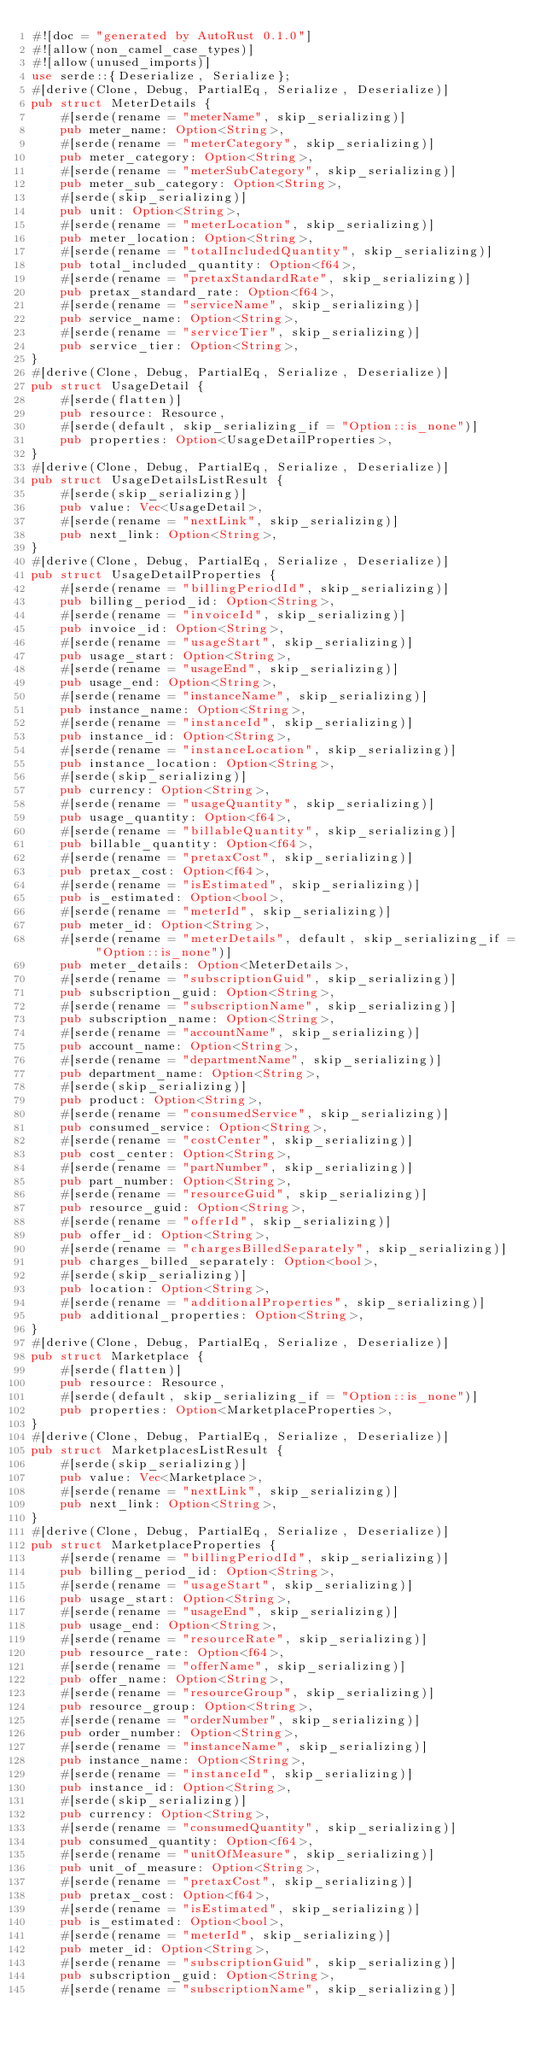Convert code to text. <code><loc_0><loc_0><loc_500><loc_500><_Rust_>#![doc = "generated by AutoRust 0.1.0"]
#![allow(non_camel_case_types)]
#![allow(unused_imports)]
use serde::{Deserialize, Serialize};
#[derive(Clone, Debug, PartialEq, Serialize, Deserialize)]
pub struct MeterDetails {
    #[serde(rename = "meterName", skip_serializing)]
    pub meter_name: Option<String>,
    #[serde(rename = "meterCategory", skip_serializing)]
    pub meter_category: Option<String>,
    #[serde(rename = "meterSubCategory", skip_serializing)]
    pub meter_sub_category: Option<String>,
    #[serde(skip_serializing)]
    pub unit: Option<String>,
    #[serde(rename = "meterLocation", skip_serializing)]
    pub meter_location: Option<String>,
    #[serde(rename = "totalIncludedQuantity", skip_serializing)]
    pub total_included_quantity: Option<f64>,
    #[serde(rename = "pretaxStandardRate", skip_serializing)]
    pub pretax_standard_rate: Option<f64>,
    #[serde(rename = "serviceName", skip_serializing)]
    pub service_name: Option<String>,
    #[serde(rename = "serviceTier", skip_serializing)]
    pub service_tier: Option<String>,
}
#[derive(Clone, Debug, PartialEq, Serialize, Deserialize)]
pub struct UsageDetail {
    #[serde(flatten)]
    pub resource: Resource,
    #[serde(default, skip_serializing_if = "Option::is_none")]
    pub properties: Option<UsageDetailProperties>,
}
#[derive(Clone, Debug, PartialEq, Serialize, Deserialize)]
pub struct UsageDetailsListResult {
    #[serde(skip_serializing)]
    pub value: Vec<UsageDetail>,
    #[serde(rename = "nextLink", skip_serializing)]
    pub next_link: Option<String>,
}
#[derive(Clone, Debug, PartialEq, Serialize, Deserialize)]
pub struct UsageDetailProperties {
    #[serde(rename = "billingPeriodId", skip_serializing)]
    pub billing_period_id: Option<String>,
    #[serde(rename = "invoiceId", skip_serializing)]
    pub invoice_id: Option<String>,
    #[serde(rename = "usageStart", skip_serializing)]
    pub usage_start: Option<String>,
    #[serde(rename = "usageEnd", skip_serializing)]
    pub usage_end: Option<String>,
    #[serde(rename = "instanceName", skip_serializing)]
    pub instance_name: Option<String>,
    #[serde(rename = "instanceId", skip_serializing)]
    pub instance_id: Option<String>,
    #[serde(rename = "instanceLocation", skip_serializing)]
    pub instance_location: Option<String>,
    #[serde(skip_serializing)]
    pub currency: Option<String>,
    #[serde(rename = "usageQuantity", skip_serializing)]
    pub usage_quantity: Option<f64>,
    #[serde(rename = "billableQuantity", skip_serializing)]
    pub billable_quantity: Option<f64>,
    #[serde(rename = "pretaxCost", skip_serializing)]
    pub pretax_cost: Option<f64>,
    #[serde(rename = "isEstimated", skip_serializing)]
    pub is_estimated: Option<bool>,
    #[serde(rename = "meterId", skip_serializing)]
    pub meter_id: Option<String>,
    #[serde(rename = "meterDetails", default, skip_serializing_if = "Option::is_none")]
    pub meter_details: Option<MeterDetails>,
    #[serde(rename = "subscriptionGuid", skip_serializing)]
    pub subscription_guid: Option<String>,
    #[serde(rename = "subscriptionName", skip_serializing)]
    pub subscription_name: Option<String>,
    #[serde(rename = "accountName", skip_serializing)]
    pub account_name: Option<String>,
    #[serde(rename = "departmentName", skip_serializing)]
    pub department_name: Option<String>,
    #[serde(skip_serializing)]
    pub product: Option<String>,
    #[serde(rename = "consumedService", skip_serializing)]
    pub consumed_service: Option<String>,
    #[serde(rename = "costCenter", skip_serializing)]
    pub cost_center: Option<String>,
    #[serde(rename = "partNumber", skip_serializing)]
    pub part_number: Option<String>,
    #[serde(rename = "resourceGuid", skip_serializing)]
    pub resource_guid: Option<String>,
    #[serde(rename = "offerId", skip_serializing)]
    pub offer_id: Option<String>,
    #[serde(rename = "chargesBilledSeparately", skip_serializing)]
    pub charges_billed_separately: Option<bool>,
    #[serde(skip_serializing)]
    pub location: Option<String>,
    #[serde(rename = "additionalProperties", skip_serializing)]
    pub additional_properties: Option<String>,
}
#[derive(Clone, Debug, PartialEq, Serialize, Deserialize)]
pub struct Marketplace {
    #[serde(flatten)]
    pub resource: Resource,
    #[serde(default, skip_serializing_if = "Option::is_none")]
    pub properties: Option<MarketplaceProperties>,
}
#[derive(Clone, Debug, PartialEq, Serialize, Deserialize)]
pub struct MarketplacesListResult {
    #[serde(skip_serializing)]
    pub value: Vec<Marketplace>,
    #[serde(rename = "nextLink", skip_serializing)]
    pub next_link: Option<String>,
}
#[derive(Clone, Debug, PartialEq, Serialize, Deserialize)]
pub struct MarketplaceProperties {
    #[serde(rename = "billingPeriodId", skip_serializing)]
    pub billing_period_id: Option<String>,
    #[serde(rename = "usageStart", skip_serializing)]
    pub usage_start: Option<String>,
    #[serde(rename = "usageEnd", skip_serializing)]
    pub usage_end: Option<String>,
    #[serde(rename = "resourceRate", skip_serializing)]
    pub resource_rate: Option<f64>,
    #[serde(rename = "offerName", skip_serializing)]
    pub offer_name: Option<String>,
    #[serde(rename = "resourceGroup", skip_serializing)]
    pub resource_group: Option<String>,
    #[serde(rename = "orderNumber", skip_serializing)]
    pub order_number: Option<String>,
    #[serde(rename = "instanceName", skip_serializing)]
    pub instance_name: Option<String>,
    #[serde(rename = "instanceId", skip_serializing)]
    pub instance_id: Option<String>,
    #[serde(skip_serializing)]
    pub currency: Option<String>,
    #[serde(rename = "consumedQuantity", skip_serializing)]
    pub consumed_quantity: Option<f64>,
    #[serde(rename = "unitOfMeasure", skip_serializing)]
    pub unit_of_measure: Option<String>,
    #[serde(rename = "pretaxCost", skip_serializing)]
    pub pretax_cost: Option<f64>,
    #[serde(rename = "isEstimated", skip_serializing)]
    pub is_estimated: Option<bool>,
    #[serde(rename = "meterId", skip_serializing)]
    pub meter_id: Option<String>,
    #[serde(rename = "subscriptionGuid", skip_serializing)]
    pub subscription_guid: Option<String>,
    #[serde(rename = "subscriptionName", skip_serializing)]</code> 